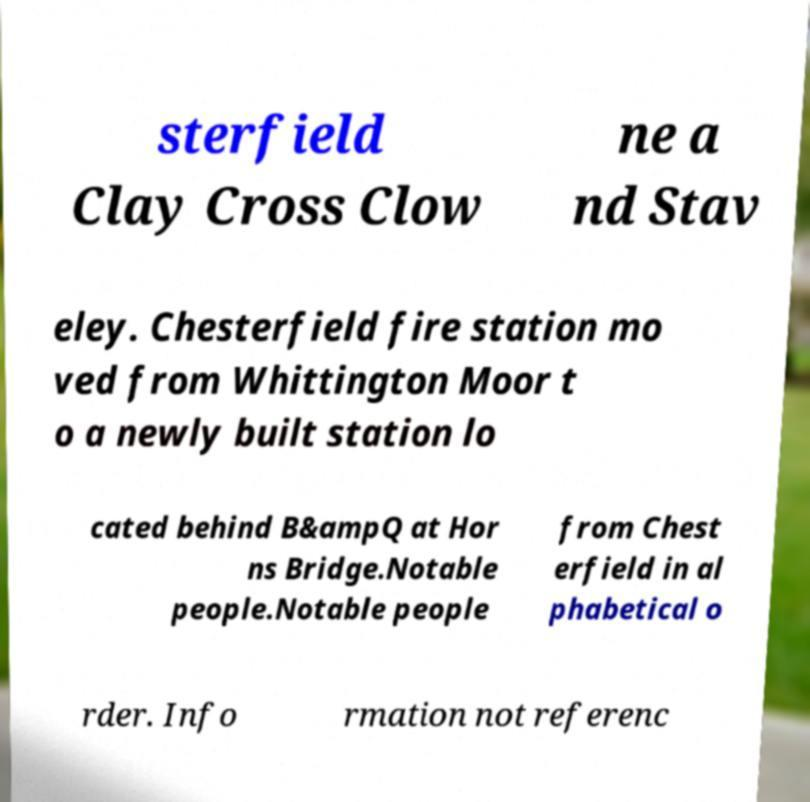What messages or text are displayed in this image? I need them in a readable, typed format. sterfield Clay Cross Clow ne a nd Stav eley. Chesterfield fire station mo ved from Whittington Moor t o a newly built station lo cated behind B&ampQ at Hor ns Bridge.Notable people.Notable people from Chest erfield in al phabetical o rder. Info rmation not referenc 